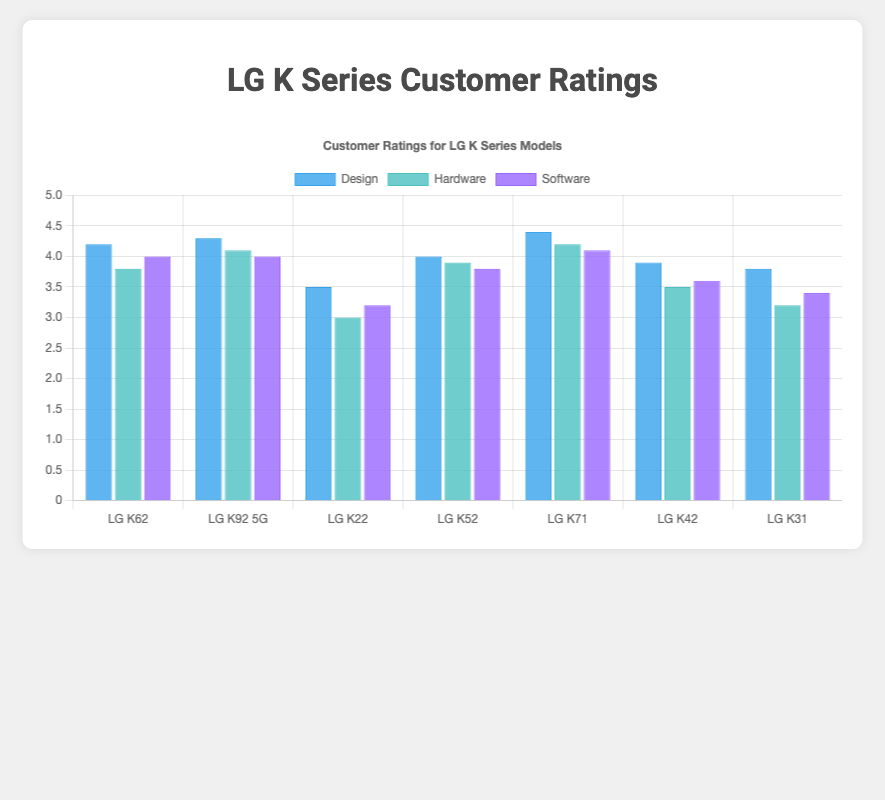Which LG K Series model has the highest rating for design? The chart shows the ratings for design with different heights for each model's bar. The tallest bar in the design category corresponds to the LG K71 with a rating of 4.4.
Answer: LG K71 Which model has the lowest hardware rating? By comparing the heights of the bars in the hardware category, the shortest bar is for the LG K22, which has a hardware rating of 3.0.
Answer: LG K22 What is the average customer rating for the software category across all models? To find the average rating for software, sum all software ratings and divide by the number of models. \( \frac{(4.0 + 4.0 + 3.2 + 3.8 + 4.1 + 3.6 + 3.4)}{7} = 3.87 \)
Answer: 3.87 Which two models have the closest design ratings and what are those ratings? By looking at the design ratings, LG K92 5G and LG K62 have the closest design ratings of 4.3 and 4.2 respectively, differing by only 0.1.
Answer: LG K92 5G (4.3) and LG K62 (4.2) Compare the software ratings of LG K71 and LG K31. Which has the higher rating and by how much? The software ratings for LG K71 and LG K31 are 4.1 and 3.4 respectively. LG K71 has a higher rating by \(4.1 - 3.4 = 0.7\).
Answer: LG K71 by 0.7 If we consider only hardware ratings, which model performs better, LG K62 or LG K42? The hardware rating for LG K62 is 3.8, and for LG K42 it's 3.5. LG K62 performs better in hardware.
Answer: LG K62 How many models have a design rating of 4.0 or higher? Visually counting the bars in the design category that reach or exceed the 4.0 mark, there are 5 models: LG K62, LG K92 5G, LG K52, LG K71, and LG K42.
Answer: 5 What is the sum of the hardware ratings for LG K62, LG K92 5G, and LG K71? The hardware ratings for LG K62, LG K92 5G, and LG K71 are 3.8, 4.1, and 4.2 respectively. Summing them up: \(3.8 + 4.1 + 4.2 = 12.1\).
Answer: 12.1 Which model has the most balanced ratings (design, hardware, software)? By inspecting the differences among the three ratings (design, hardware, software) for each model, LG K52 has ratings closest to each other: design (4.0), hardware (3.9), and software (3.8).
Answer: LG K52 